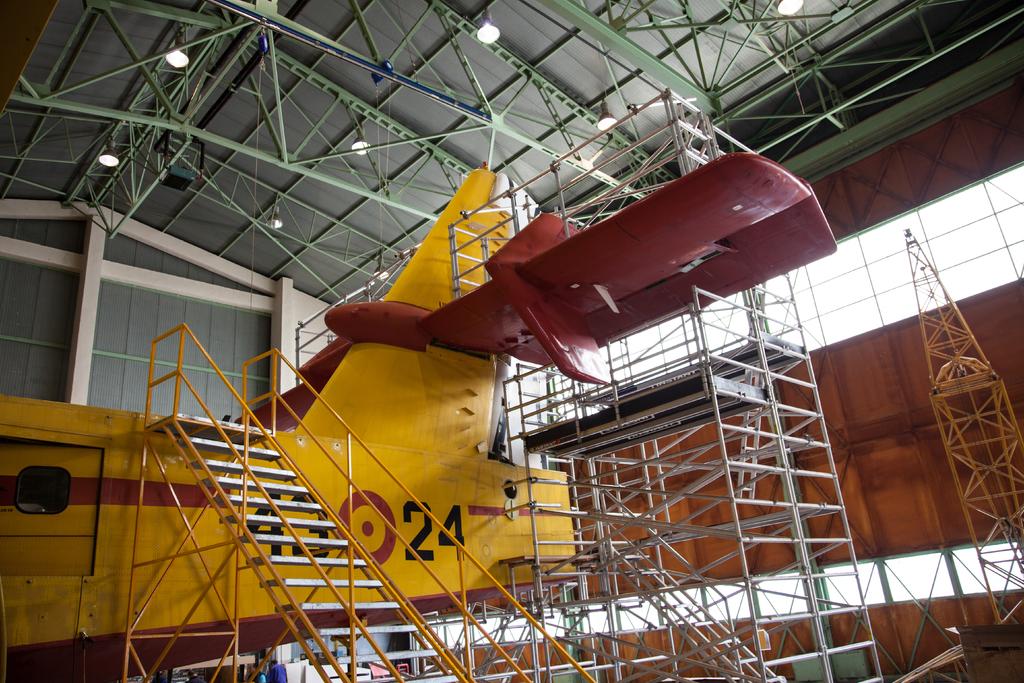What is the number on the yellow plane?
Your response must be concise. 24. 